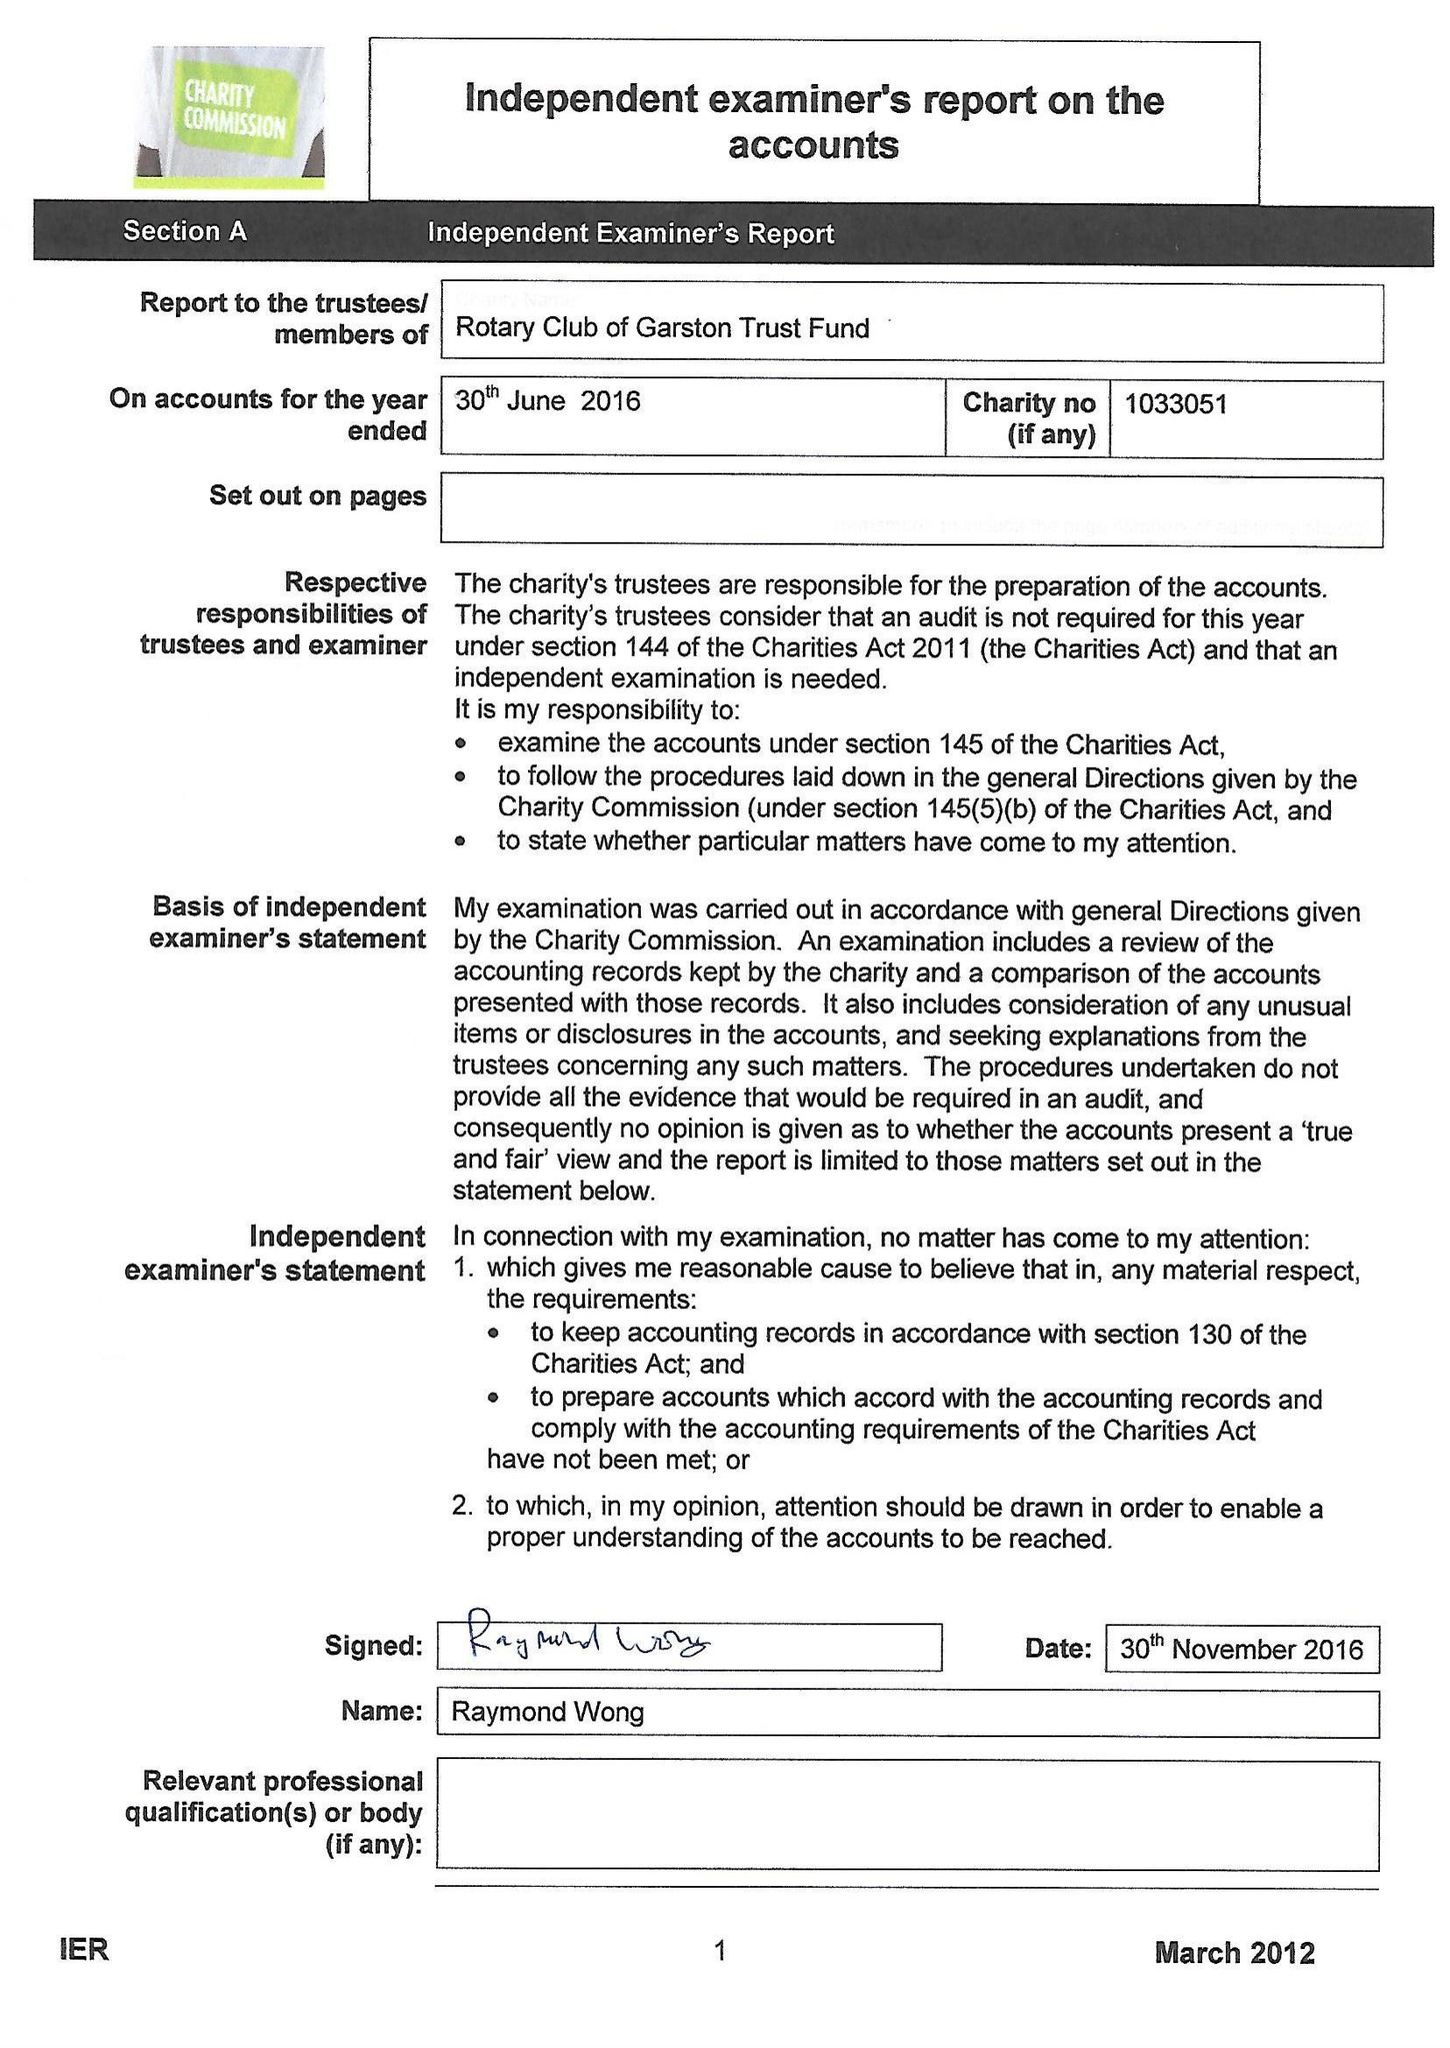What is the value for the address__street_line?
Answer the question using a single word or phrase. 47 BALLANTRAE ROAD 